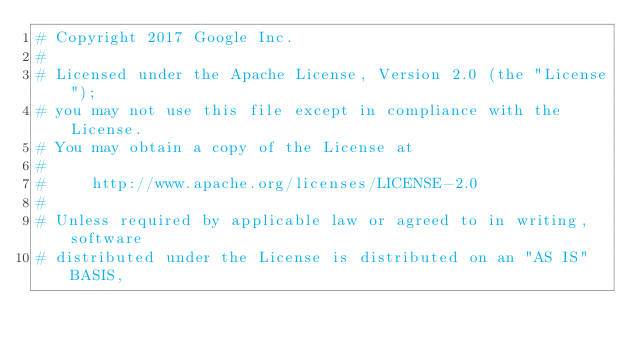<code> <loc_0><loc_0><loc_500><loc_500><_Python_># Copyright 2017 Google Inc.
# 
# Licensed under the Apache License, Version 2.0 (the "License");
# you may not use this file except in compliance with the License.
# You may obtain a copy of the License at
# 
#     http://www.apache.org/licenses/LICENSE-2.0
# 
# Unless required by applicable law or agreed to in writing, software
# distributed under the License is distributed on an "AS IS" BASIS,</code> 